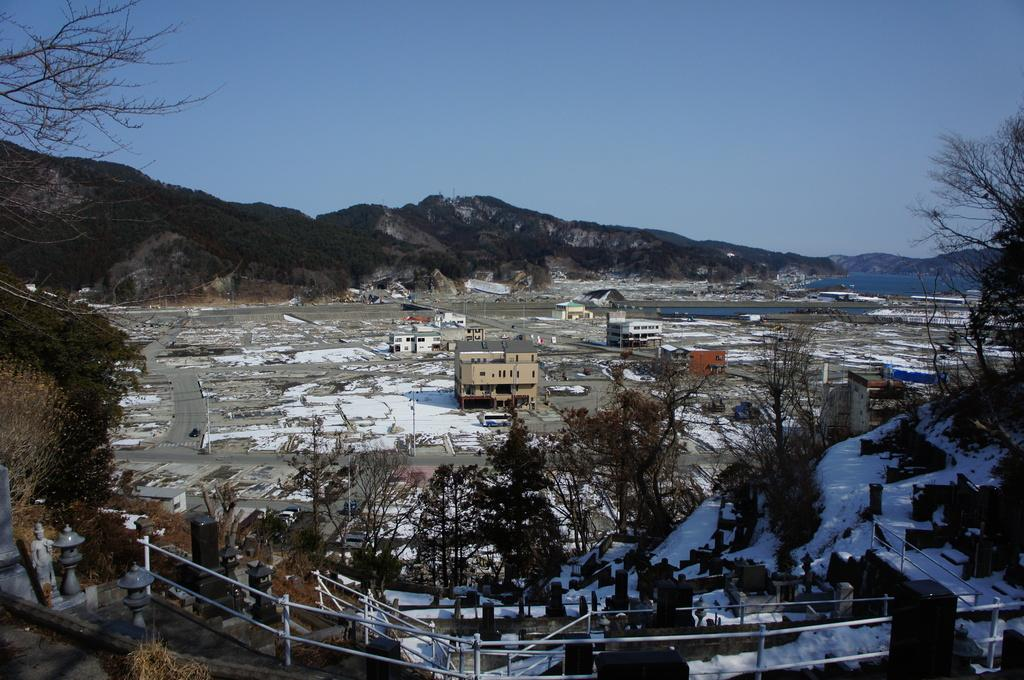What type of vegetation is present in the image? There are many trees in the image. What type of structures can be seen in the image? There are buildings in the image. What is located in the foreground of the image? There are fences in the foreground of the image. What can be seen in the background of the image? There are trees and hills in the background of the image. What is the condition of the ground in the image? There is snow on the ground. What is the condition of the sky in the image? The sky is clear in the image. How many fifths are present in the image? There is no reference to a "fifth" in the image, so it is not possible to answer that question. What type of land is being used for agricultural purposes in the image? There is no indication of agricultural land or any farming activities in the image. 